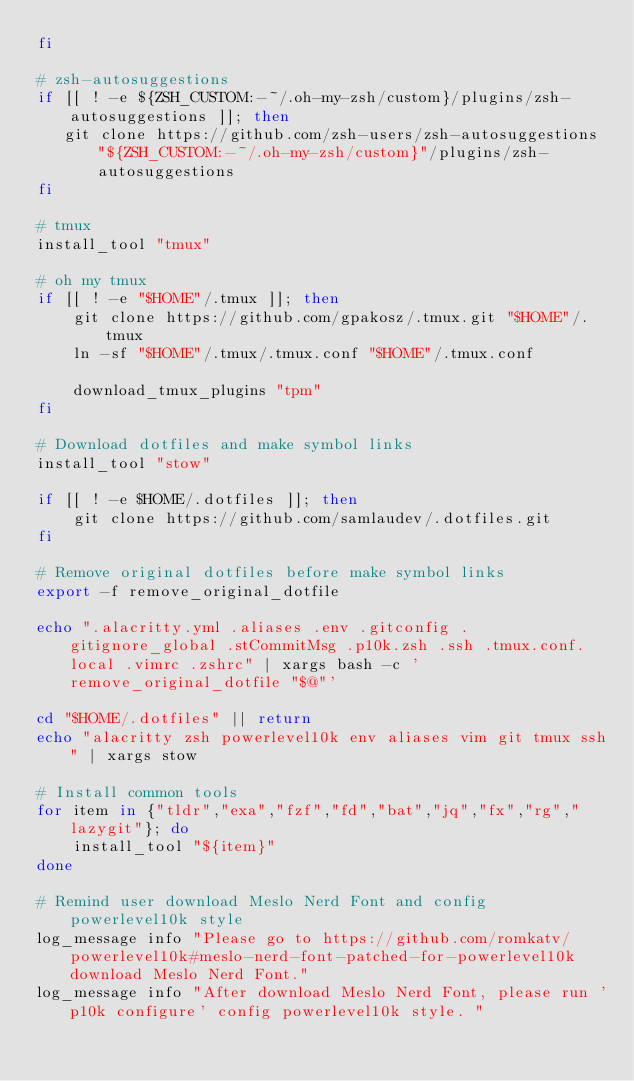Convert code to text. <code><loc_0><loc_0><loc_500><loc_500><_Bash_>fi

# zsh-autosuggestions
if [[ ! -e ${ZSH_CUSTOM:-~/.oh-my-zsh/custom}/plugins/zsh-autosuggestions ]]; then
   git clone https://github.com/zsh-users/zsh-autosuggestions "${ZSH_CUSTOM:-~/.oh-my-zsh/custom}"/plugins/zsh-autosuggestions 
fi

# tmux
install_tool "tmux"

# oh my tmux
if [[ ! -e "$HOME"/.tmux ]]; then
    git clone https://github.com/gpakosz/.tmux.git "$HOME"/.tmux
    ln -sf "$HOME"/.tmux/.tmux.conf "$HOME"/.tmux.conf
    
    download_tmux_plugins "tpm"
fi

# Download dotfiles and make symbol links
install_tool "stow"

if [[ ! -e $HOME/.dotfiles ]]; then
    git clone https://github.com/samlaudev/.dotfiles.git
fi

# Remove original dotfiles before make symbol links
export -f remove_original_dotfile

echo ".alacritty.yml .aliases .env .gitconfig .gitignore_global .stCommitMsg .p10k.zsh .ssh .tmux.conf.local .vimrc .zshrc" | xargs bash -c 'remove_original_dotfile "$@"'

cd "$HOME/.dotfiles" || return 
echo "alacritty zsh powerlevel10k env aliases vim git tmux ssh" | xargs stow

# Install common tools
for item in {"tldr","exa","fzf","fd","bat","jq","fx","rg","lazygit"}; do
    install_tool "${item}"
done

# Remind user download Meslo Nerd Font and config powerlevel10k style
log_message info "Please go to https://github.com/romkatv/powerlevel10k#meslo-nerd-font-patched-for-powerlevel10k download Meslo Nerd Font."
log_message info "After download Meslo Nerd Font, please run 'p10k configure' config powerlevel10k style. "
</code> 